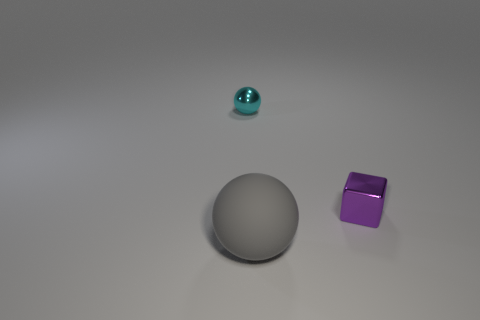Add 1 small gray metal things. How many objects exist? 4 Subtract all spheres. How many objects are left? 1 Add 1 small red metallic spheres. How many small red metallic spheres exist? 1 Subtract 0 yellow blocks. How many objects are left? 3 Subtract all tiny purple metal objects. Subtract all big gray matte things. How many objects are left? 1 Add 2 gray spheres. How many gray spheres are left? 3 